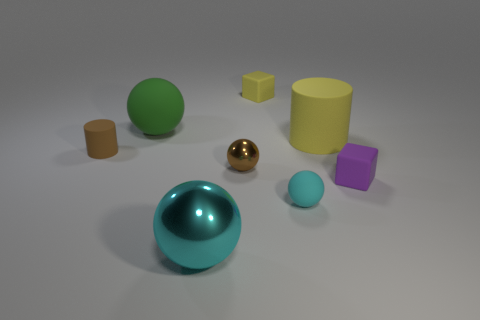There is a block that is the same color as the large rubber cylinder; what is it made of?
Offer a terse response. Rubber. Are there any other spheres that have the same color as the large metallic ball?
Make the answer very short. Yes. Does the small brown object to the left of the small brown metal object have the same shape as the yellow rubber object behind the green rubber ball?
Your answer should be very brief. No. What is the color of the cylinder that is the same size as the purple matte cube?
Your answer should be very brief. Brown. There is a shiny object in front of the tiny shiny object; what number of cyan metal objects are behind it?
Provide a short and direct response. 0. How many rubber objects are both behind the brown rubber cylinder and left of the big metal ball?
Ensure brevity in your answer.  1. The yellow rubber object that is behind the large rubber thing left of the small yellow matte thing is what shape?
Provide a succinct answer. Cube. There is a metal thing that is to the right of the cyan shiny ball; is its color the same as the matte cylinder to the left of the yellow matte block?
Your answer should be very brief. Yes. Is there any other thing of the same color as the big shiny object?
Offer a very short reply. Yes. There is another thing that is the same shape as the tiny yellow thing; what material is it?
Your answer should be very brief. Rubber. 